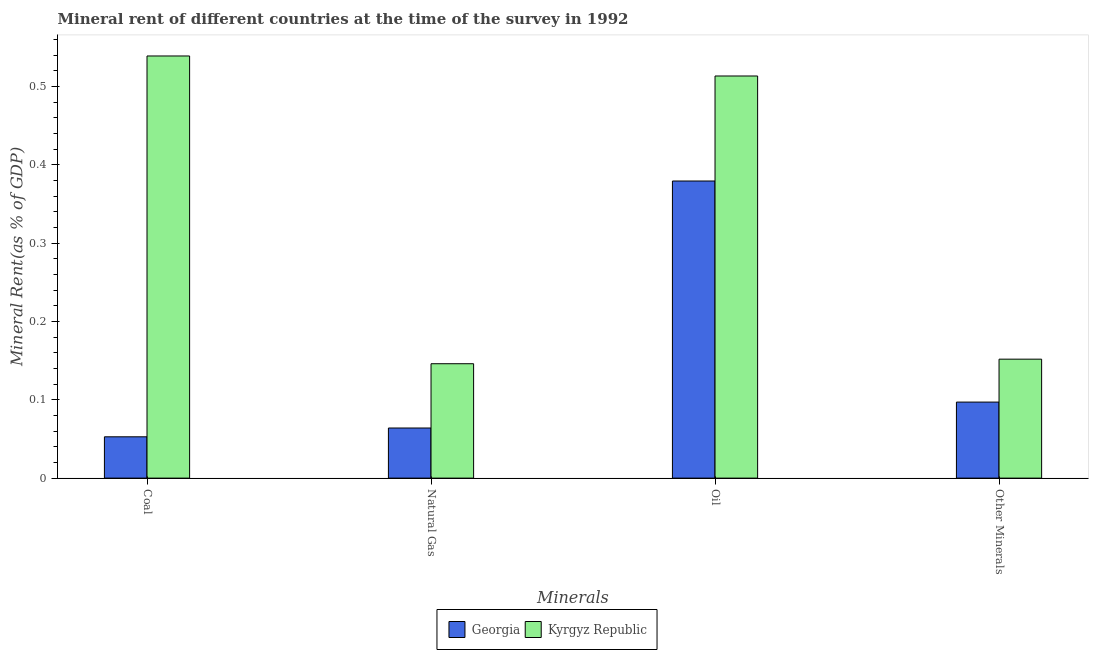How many different coloured bars are there?
Ensure brevity in your answer.  2. How many groups of bars are there?
Make the answer very short. 4. Are the number of bars per tick equal to the number of legend labels?
Provide a succinct answer. Yes. Are the number of bars on each tick of the X-axis equal?
Give a very brief answer. Yes. What is the label of the 3rd group of bars from the left?
Provide a succinct answer. Oil. What is the natural gas rent in Kyrgyz Republic?
Offer a very short reply. 0.15. Across all countries, what is the maximum coal rent?
Provide a succinct answer. 0.54. Across all countries, what is the minimum coal rent?
Your answer should be compact. 0.05. In which country was the coal rent maximum?
Give a very brief answer. Kyrgyz Republic. In which country was the coal rent minimum?
Offer a very short reply. Georgia. What is the total coal rent in the graph?
Provide a succinct answer. 0.59. What is the difference between the oil rent in Georgia and that in Kyrgyz Republic?
Keep it short and to the point. -0.13. What is the difference between the  rent of other minerals in Georgia and the natural gas rent in Kyrgyz Republic?
Ensure brevity in your answer.  -0.05. What is the average  rent of other minerals per country?
Your response must be concise. 0.12. What is the difference between the oil rent and coal rent in Georgia?
Provide a succinct answer. 0.33. What is the ratio of the  rent of other minerals in Georgia to that in Kyrgyz Republic?
Provide a succinct answer. 0.64. Is the difference between the natural gas rent in Kyrgyz Republic and Georgia greater than the difference between the  rent of other minerals in Kyrgyz Republic and Georgia?
Provide a short and direct response. Yes. What is the difference between the highest and the second highest oil rent?
Provide a short and direct response. 0.13. What is the difference between the highest and the lowest coal rent?
Your answer should be compact. 0.49. In how many countries, is the coal rent greater than the average coal rent taken over all countries?
Make the answer very short. 1. What does the 1st bar from the left in Other Minerals represents?
Your response must be concise. Georgia. What does the 1st bar from the right in Other Minerals represents?
Your answer should be very brief. Kyrgyz Republic. Are all the bars in the graph horizontal?
Provide a short and direct response. No. How many countries are there in the graph?
Make the answer very short. 2. Does the graph contain any zero values?
Give a very brief answer. No. How many legend labels are there?
Offer a terse response. 2. How are the legend labels stacked?
Keep it short and to the point. Horizontal. What is the title of the graph?
Offer a terse response. Mineral rent of different countries at the time of the survey in 1992. What is the label or title of the X-axis?
Your response must be concise. Minerals. What is the label or title of the Y-axis?
Your response must be concise. Mineral Rent(as % of GDP). What is the Mineral Rent(as % of GDP) of Georgia in Coal?
Provide a short and direct response. 0.05. What is the Mineral Rent(as % of GDP) in Kyrgyz Republic in Coal?
Ensure brevity in your answer.  0.54. What is the Mineral Rent(as % of GDP) of Georgia in Natural Gas?
Make the answer very short. 0.06. What is the Mineral Rent(as % of GDP) of Kyrgyz Republic in Natural Gas?
Offer a terse response. 0.15. What is the Mineral Rent(as % of GDP) in Georgia in Oil?
Keep it short and to the point. 0.38. What is the Mineral Rent(as % of GDP) in Kyrgyz Republic in Oil?
Make the answer very short. 0.51. What is the Mineral Rent(as % of GDP) in Georgia in Other Minerals?
Your answer should be compact. 0.1. What is the Mineral Rent(as % of GDP) in Kyrgyz Republic in Other Minerals?
Provide a succinct answer. 0.15. Across all Minerals, what is the maximum Mineral Rent(as % of GDP) of Georgia?
Provide a succinct answer. 0.38. Across all Minerals, what is the maximum Mineral Rent(as % of GDP) in Kyrgyz Republic?
Ensure brevity in your answer.  0.54. Across all Minerals, what is the minimum Mineral Rent(as % of GDP) of Georgia?
Keep it short and to the point. 0.05. Across all Minerals, what is the minimum Mineral Rent(as % of GDP) of Kyrgyz Republic?
Give a very brief answer. 0.15. What is the total Mineral Rent(as % of GDP) of Georgia in the graph?
Give a very brief answer. 0.59. What is the total Mineral Rent(as % of GDP) of Kyrgyz Republic in the graph?
Your answer should be very brief. 1.35. What is the difference between the Mineral Rent(as % of GDP) in Georgia in Coal and that in Natural Gas?
Your answer should be compact. -0.01. What is the difference between the Mineral Rent(as % of GDP) in Kyrgyz Republic in Coal and that in Natural Gas?
Offer a very short reply. 0.39. What is the difference between the Mineral Rent(as % of GDP) in Georgia in Coal and that in Oil?
Keep it short and to the point. -0.33. What is the difference between the Mineral Rent(as % of GDP) of Kyrgyz Republic in Coal and that in Oil?
Make the answer very short. 0.03. What is the difference between the Mineral Rent(as % of GDP) in Georgia in Coal and that in Other Minerals?
Your answer should be compact. -0.04. What is the difference between the Mineral Rent(as % of GDP) of Kyrgyz Republic in Coal and that in Other Minerals?
Provide a short and direct response. 0.39. What is the difference between the Mineral Rent(as % of GDP) in Georgia in Natural Gas and that in Oil?
Offer a terse response. -0.32. What is the difference between the Mineral Rent(as % of GDP) in Kyrgyz Republic in Natural Gas and that in Oil?
Keep it short and to the point. -0.37. What is the difference between the Mineral Rent(as % of GDP) in Georgia in Natural Gas and that in Other Minerals?
Make the answer very short. -0.03. What is the difference between the Mineral Rent(as % of GDP) of Kyrgyz Republic in Natural Gas and that in Other Minerals?
Offer a terse response. -0.01. What is the difference between the Mineral Rent(as % of GDP) of Georgia in Oil and that in Other Minerals?
Your answer should be compact. 0.28. What is the difference between the Mineral Rent(as % of GDP) of Kyrgyz Republic in Oil and that in Other Minerals?
Your answer should be very brief. 0.36. What is the difference between the Mineral Rent(as % of GDP) of Georgia in Coal and the Mineral Rent(as % of GDP) of Kyrgyz Republic in Natural Gas?
Give a very brief answer. -0.09. What is the difference between the Mineral Rent(as % of GDP) of Georgia in Coal and the Mineral Rent(as % of GDP) of Kyrgyz Republic in Oil?
Your response must be concise. -0.46. What is the difference between the Mineral Rent(as % of GDP) in Georgia in Coal and the Mineral Rent(as % of GDP) in Kyrgyz Republic in Other Minerals?
Keep it short and to the point. -0.1. What is the difference between the Mineral Rent(as % of GDP) of Georgia in Natural Gas and the Mineral Rent(as % of GDP) of Kyrgyz Republic in Oil?
Offer a very short reply. -0.45. What is the difference between the Mineral Rent(as % of GDP) of Georgia in Natural Gas and the Mineral Rent(as % of GDP) of Kyrgyz Republic in Other Minerals?
Your response must be concise. -0.09. What is the difference between the Mineral Rent(as % of GDP) of Georgia in Oil and the Mineral Rent(as % of GDP) of Kyrgyz Republic in Other Minerals?
Your answer should be very brief. 0.23. What is the average Mineral Rent(as % of GDP) of Georgia per Minerals?
Provide a succinct answer. 0.15. What is the average Mineral Rent(as % of GDP) of Kyrgyz Republic per Minerals?
Your answer should be very brief. 0.34. What is the difference between the Mineral Rent(as % of GDP) in Georgia and Mineral Rent(as % of GDP) in Kyrgyz Republic in Coal?
Your response must be concise. -0.49. What is the difference between the Mineral Rent(as % of GDP) of Georgia and Mineral Rent(as % of GDP) of Kyrgyz Republic in Natural Gas?
Your answer should be compact. -0.08. What is the difference between the Mineral Rent(as % of GDP) in Georgia and Mineral Rent(as % of GDP) in Kyrgyz Republic in Oil?
Ensure brevity in your answer.  -0.13. What is the difference between the Mineral Rent(as % of GDP) of Georgia and Mineral Rent(as % of GDP) of Kyrgyz Republic in Other Minerals?
Provide a short and direct response. -0.05. What is the ratio of the Mineral Rent(as % of GDP) of Georgia in Coal to that in Natural Gas?
Give a very brief answer. 0.82. What is the ratio of the Mineral Rent(as % of GDP) of Kyrgyz Republic in Coal to that in Natural Gas?
Your answer should be compact. 3.69. What is the ratio of the Mineral Rent(as % of GDP) in Georgia in Coal to that in Oil?
Ensure brevity in your answer.  0.14. What is the ratio of the Mineral Rent(as % of GDP) of Kyrgyz Republic in Coal to that in Oil?
Keep it short and to the point. 1.05. What is the ratio of the Mineral Rent(as % of GDP) of Georgia in Coal to that in Other Minerals?
Your answer should be compact. 0.54. What is the ratio of the Mineral Rent(as % of GDP) of Kyrgyz Republic in Coal to that in Other Minerals?
Make the answer very short. 3.55. What is the ratio of the Mineral Rent(as % of GDP) of Georgia in Natural Gas to that in Oil?
Offer a terse response. 0.17. What is the ratio of the Mineral Rent(as % of GDP) of Kyrgyz Republic in Natural Gas to that in Oil?
Provide a succinct answer. 0.28. What is the ratio of the Mineral Rent(as % of GDP) of Georgia in Natural Gas to that in Other Minerals?
Give a very brief answer. 0.66. What is the ratio of the Mineral Rent(as % of GDP) of Kyrgyz Republic in Natural Gas to that in Other Minerals?
Keep it short and to the point. 0.96. What is the ratio of the Mineral Rent(as % of GDP) of Georgia in Oil to that in Other Minerals?
Your answer should be very brief. 3.91. What is the ratio of the Mineral Rent(as % of GDP) in Kyrgyz Republic in Oil to that in Other Minerals?
Your response must be concise. 3.38. What is the difference between the highest and the second highest Mineral Rent(as % of GDP) in Georgia?
Make the answer very short. 0.28. What is the difference between the highest and the second highest Mineral Rent(as % of GDP) of Kyrgyz Republic?
Offer a very short reply. 0.03. What is the difference between the highest and the lowest Mineral Rent(as % of GDP) in Georgia?
Provide a succinct answer. 0.33. What is the difference between the highest and the lowest Mineral Rent(as % of GDP) in Kyrgyz Republic?
Provide a short and direct response. 0.39. 